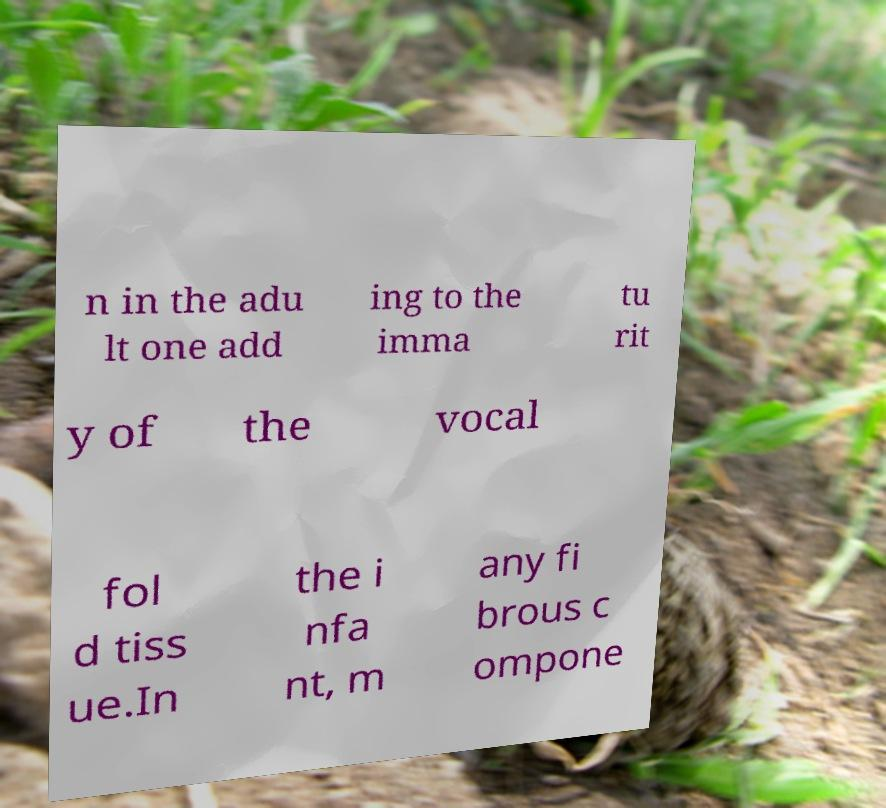There's text embedded in this image that I need extracted. Can you transcribe it verbatim? n in the adu lt one add ing to the imma tu rit y of the vocal fol d tiss ue.In the i nfa nt, m any fi brous c ompone 